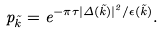Convert formula to latex. <formula><loc_0><loc_0><loc_500><loc_500>p _ { \vec { k } } = e ^ { - \pi \tau | \Delta ( { \vec { k } } ) | ^ { 2 } / \epsilon ( { \vec { k } } ) } .</formula> 